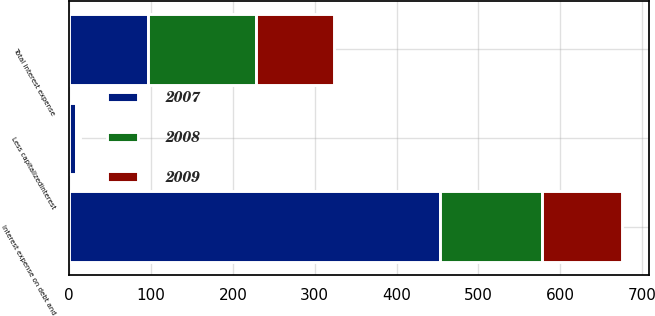Convert chart to OTSL. <chart><loc_0><loc_0><loc_500><loc_500><stacked_bar_chart><ecel><fcel>Interest expense on debt and<fcel>Less capitalizedinterest<fcel>Total interest expense<nl><fcel>2007<fcel>453.5<fcel>7.8<fcel>96.3<nl><fcel>2008<fcel>123.9<fcel>2.6<fcel>131.9<nl><fcel>2009<fcel>97.8<fcel>3<fcel>94.8<nl></chart> 